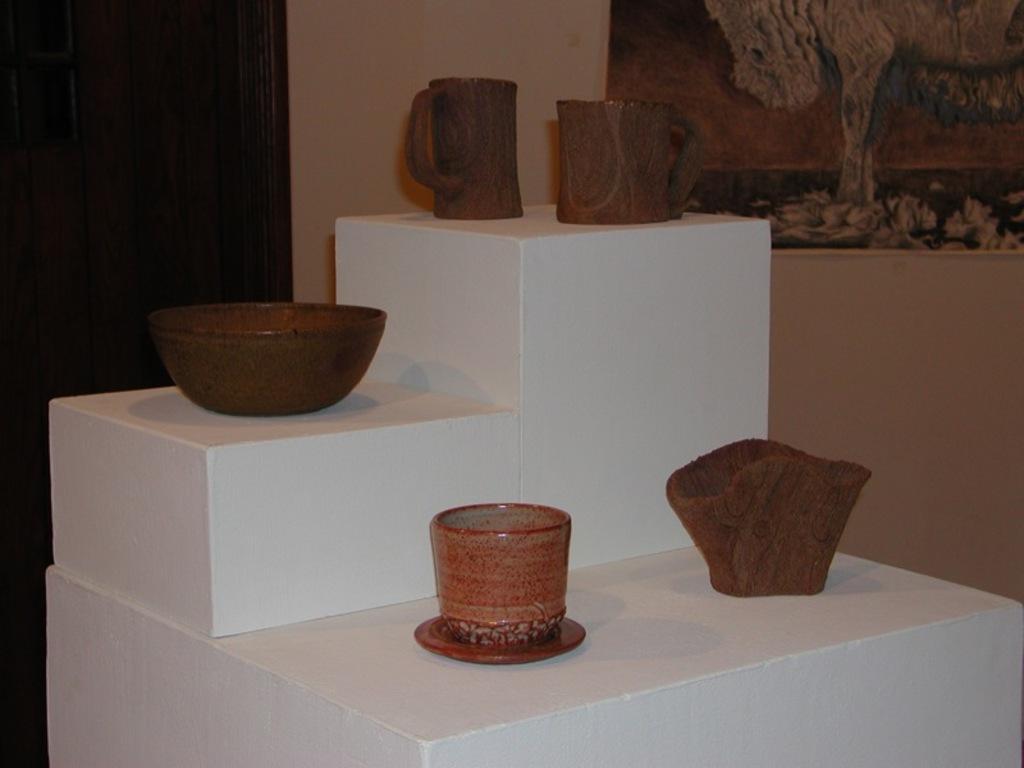Could you give a brief overview of what you see in this image? In this image at front artifacts were displayed. At the back side there is a door. Beside the door there is a wall and there is a poster attached to the wall. 